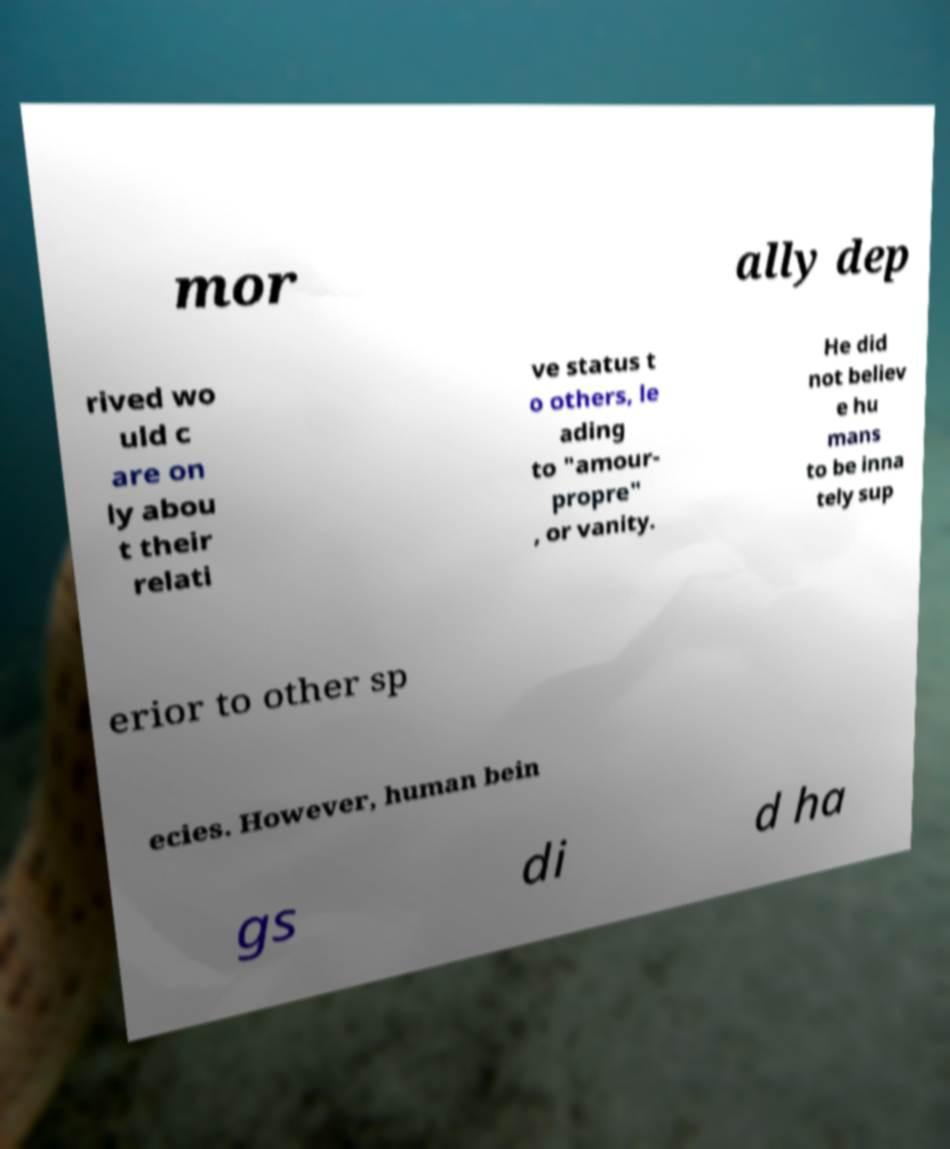For documentation purposes, I need the text within this image transcribed. Could you provide that? mor ally dep rived wo uld c are on ly abou t their relati ve status t o others, le ading to "amour- propre" , or vanity. He did not believ e hu mans to be inna tely sup erior to other sp ecies. However, human bein gs di d ha 